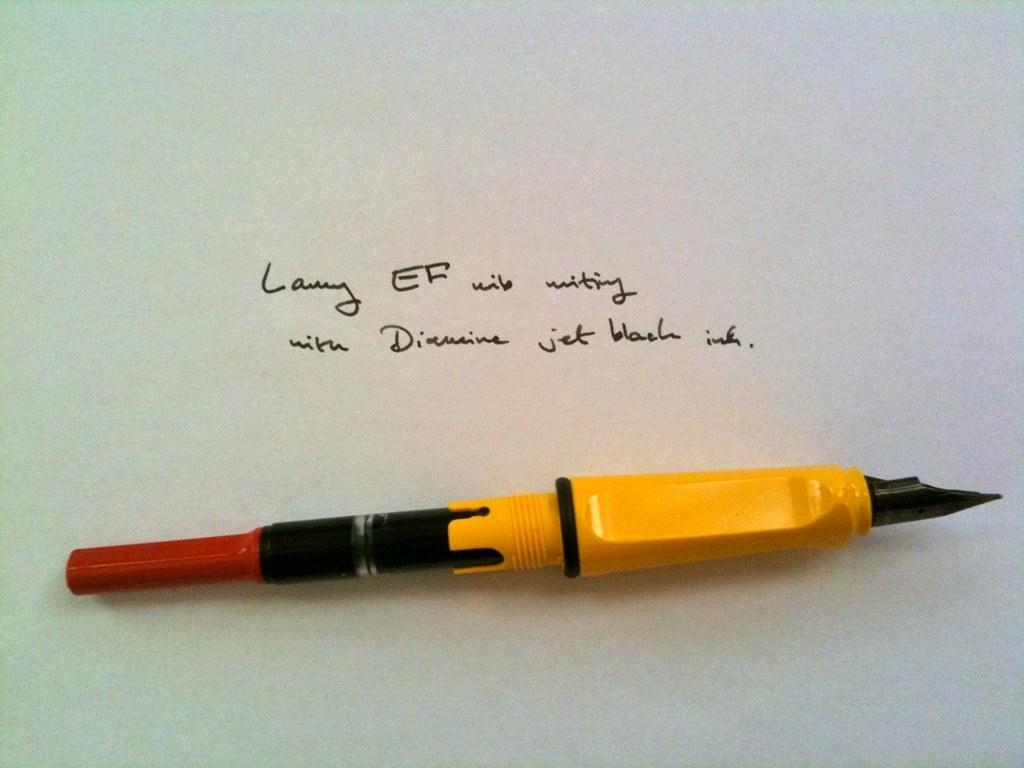What object is visible in the image that is commonly used for writing? There is an ink pen in the image. What is written or depicted in the image? There is text in the image. What is located at the bottom of the image? There is a paper at the bottom of the image. What type of can is visible in the image? There is no can present in the image. What color is the sky in the image? The provided facts do not mention the sky, so we cannot determine its color from the image. 